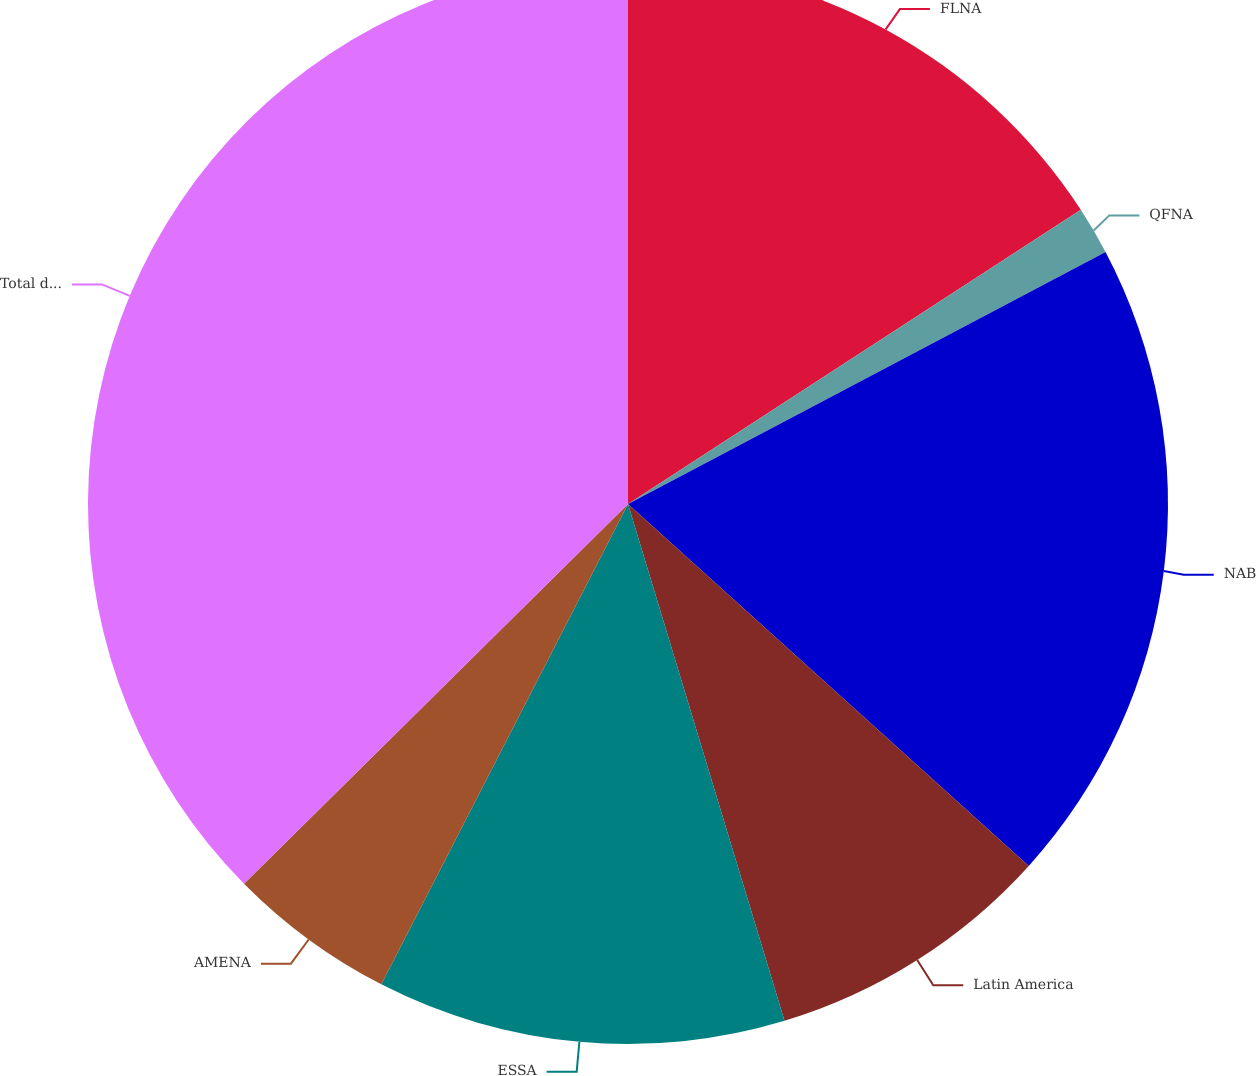Convert chart to OTSL. <chart><loc_0><loc_0><loc_500><loc_500><pie_chart><fcel>FLNA<fcel>QFNA<fcel>NAB<fcel>Latin America<fcel>ESSA<fcel>AMENA<fcel>Total division<nl><fcel>15.83%<fcel>1.44%<fcel>19.42%<fcel>8.63%<fcel>12.23%<fcel>5.04%<fcel>37.41%<nl></chart> 